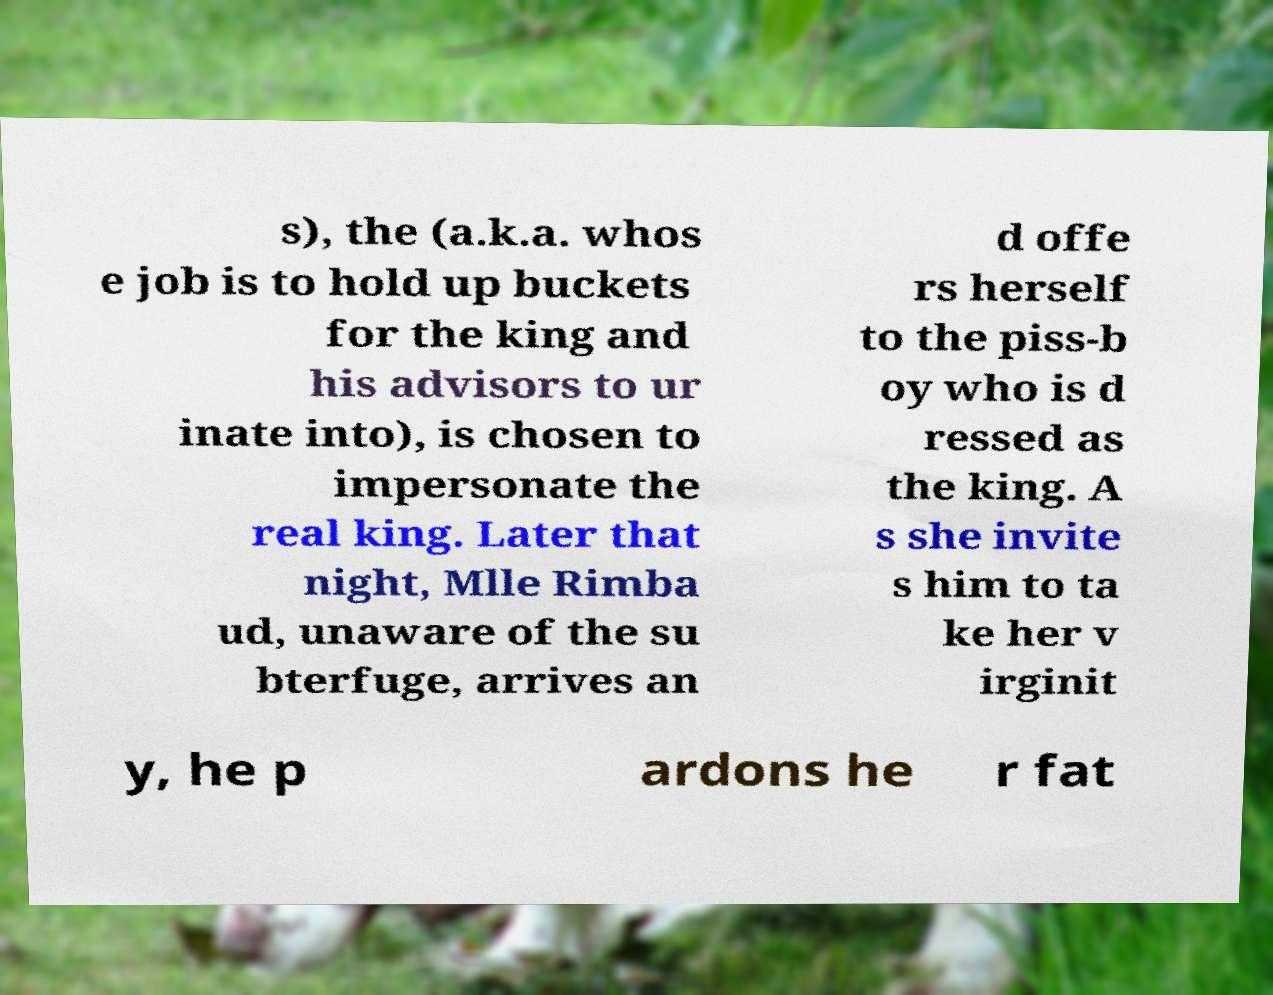For documentation purposes, I need the text within this image transcribed. Could you provide that? s), the (a.k.a. whos e job is to hold up buckets for the king and his advisors to ur inate into), is chosen to impersonate the real king. Later that night, Mlle Rimba ud, unaware of the su bterfuge, arrives an d offe rs herself to the piss-b oy who is d ressed as the king. A s she invite s him to ta ke her v irginit y, he p ardons he r fat 